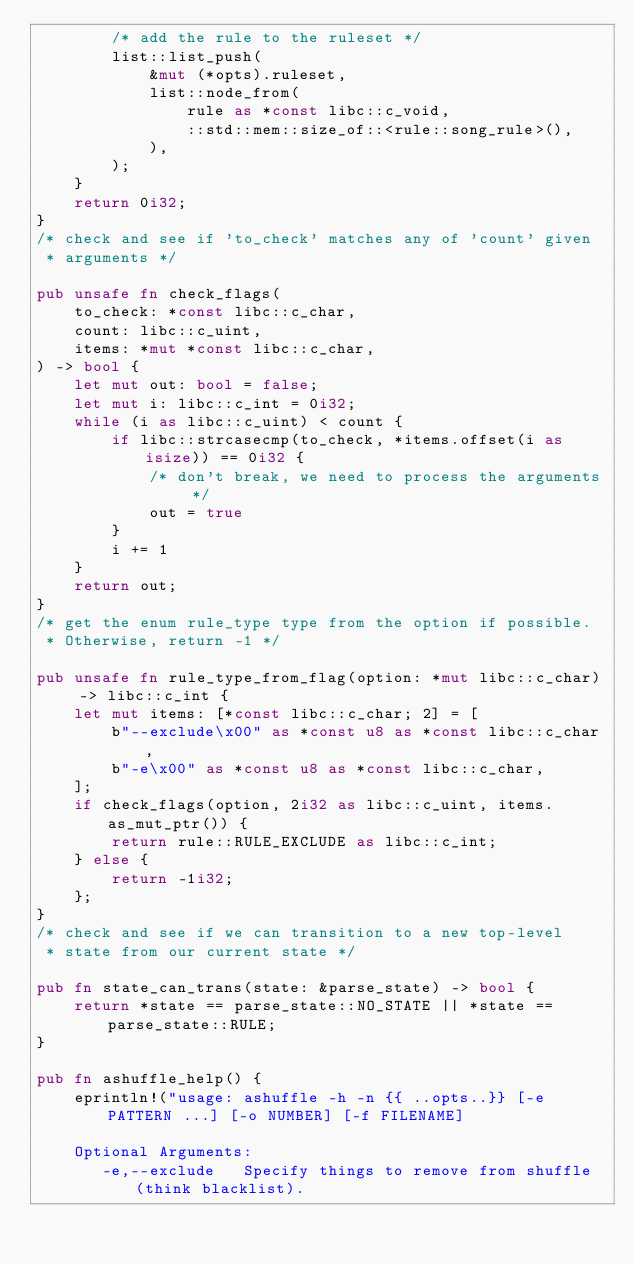<code> <loc_0><loc_0><loc_500><loc_500><_Rust_>        /* add the rule to the ruleset */
        list::list_push(
            &mut (*opts).ruleset,
            list::node_from(
                rule as *const libc::c_void,
                ::std::mem::size_of::<rule::song_rule>(),
            ),
        );
    }
    return 0i32;
}
/* check and see if 'to_check' matches any of 'count' given
 * arguments */

pub unsafe fn check_flags(
    to_check: *const libc::c_char,
    count: libc::c_uint,
    items: *mut *const libc::c_char,
) -> bool {
    let mut out: bool = false;
    let mut i: libc::c_int = 0i32;
    while (i as libc::c_uint) < count {
        if libc::strcasecmp(to_check, *items.offset(i as isize)) == 0i32 {
            /* don't break, we need to process the arguments */
            out = true
        }
        i += 1
    }
    return out;
}
/* get the enum rule_type type from the option if possible.
 * Otherwise, return -1 */

pub unsafe fn rule_type_from_flag(option: *mut libc::c_char) -> libc::c_int {
    let mut items: [*const libc::c_char; 2] = [
        b"--exclude\x00" as *const u8 as *const libc::c_char,
        b"-e\x00" as *const u8 as *const libc::c_char,
    ];
    if check_flags(option, 2i32 as libc::c_uint, items.as_mut_ptr()) {
        return rule::RULE_EXCLUDE as libc::c_int;
    } else {
        return -1i32;
    };
}
/* check and see if we can transition to a new top-level
 * state from our current state */

pub fn state_can_trans(state: &parse_state) -> bool {
    return *state == parse_state::NO_STATE || *state == parse_state::RULE;
}

pub fn ashuffle_help() {
    eprintln!("usage: ashuffle -h -n {{ ..opts..}} [-e PATTERN ...] [-o NUMBER] [-f FILENAME]
    
    Optional Arguments:
       -e,--exclude   Specify things to remove from shuffle (think blacklist).</code> 